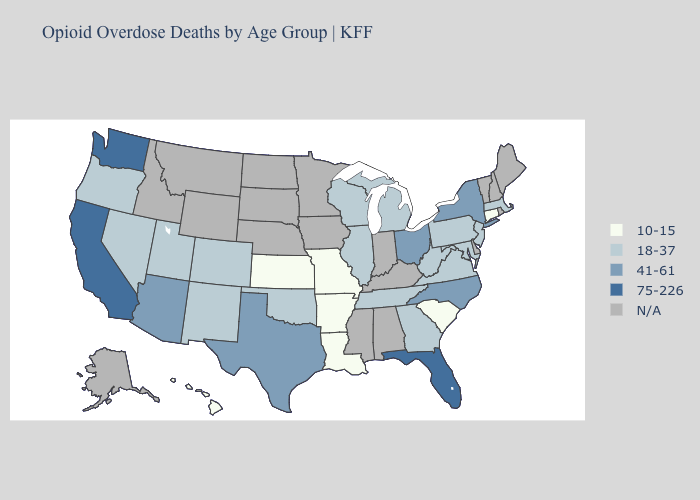What is the lowest value in the Northeast?
Be succinct. 10-15. What is the value of New Mexico?
Quick response, please. 18-37. Name the states that have a value in the range 41-61?
Quick response, please. Arizona, New York, North Carolina, Ohio, Texas. Does New York have the highest value in the Northeast?
Short answer required. Yes. Name the states that have a value in the range 10-15?
Be succinct. Arkansas, Connecticut, Hawaii, Kansas, Louisiana, Missouri, South Carolina. How many symbols are there in the legend?
Concise answer only. 5. What is the value of South Carolina?
Short answer required. 10-15. What is the highest value in the South ?
Write a very short answer. 75-226. Does Washington have the highest value in the USA?
Short answer required. Yes. Among the states that border Rhode Island , which have the highest value?
Quick response, please. Massachusetts. What is the value of Louisiana?
Quick response, please. 10-15. Name the states that have a value in the range 75-226?
Answer briefly. California, Florida, Washington. What is the value of Idaho?
Keep it brief. N/A. What is the highest value in the South ?
Answer briefly. 75-226. 